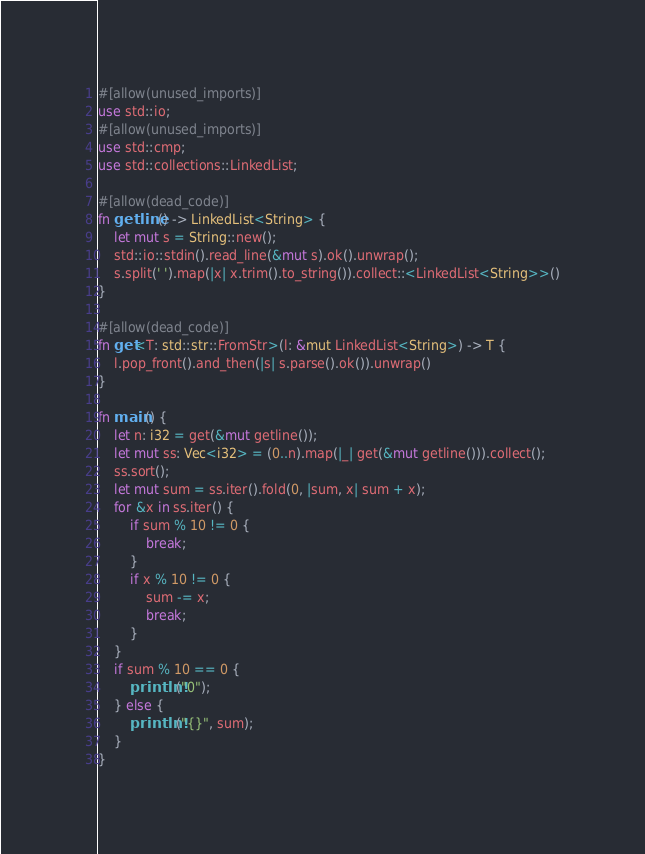<code> <loc_0><loc_0><loc_500><loc_500><_Rust_>#[allow(unused_imports)]
use std::io;
#[allow(unused_imports)]
use std::cmp;
use std::collections::LinkedList;

#[allow(dead_code)]
fn getline() -> LinkedList<String> {
    let mut s = String::new();
    std::io::stdin().read_line(&mut s).ok().unwrap();
    s.split(' ').map(|x| x.trim().to_string()).collect::<LinkedList<String>>()
}

#[allow(dead_code)]
fn get<T: std::str::FromStr>(l: &mut LinkedList<String>) -> T {
    l.pop_front().and_then(|s| s.parse().ok()).unwrap()
}

fn main() {
    let n: i32 = get(&mut getline());
    let mut ss: Vec<i32> = (0..n).map(|_| get(&mut getline())).collect();
    ss.sort();
    let mut sum = ss.iter().fold(0, |sum, x| sum + x);
    for &x in ss.iter() {
        if sum % 10 != 0 {
            break;
        }
        if x % 10 != 0 {
            sum -= x;
            break;
        }
    }
    if sum % 10 == 0 {
        println!("0");
    } else {
        println!("{}", sum);
    }
}
</code> 